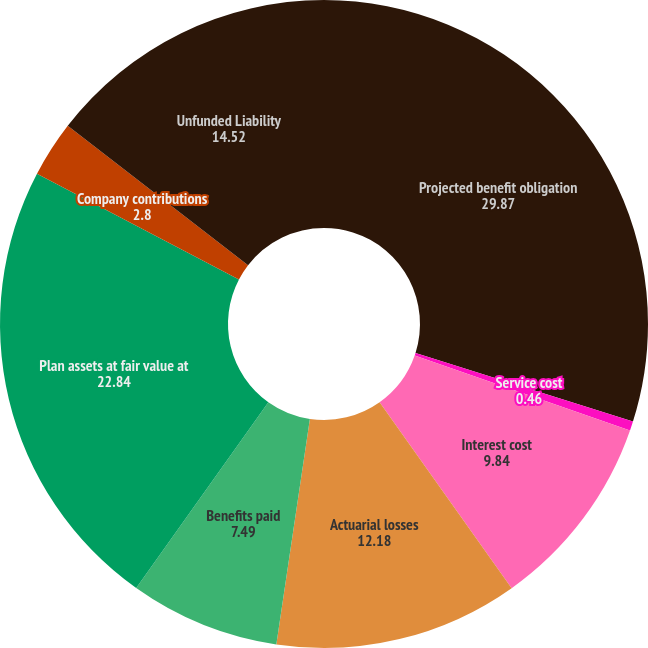<chart> <loc_0><loc_0><loc_500><loc_500><pie_chart><fcel>Projected benefit obligation<fcel>Service cost<fcel>Interest cost<fcel>Actuarial losses<fcel>Benefits paid<fcel>Plan assets at fair value at<fcel>Company contributions<fcel>Unfunded Liability<nl><fcel>29.87%<fcel>0.46%<fcel>9.84%<fcel>12.18%<fcel>7.49%<fcel>22.84%<fcel>2.8%<fcel>14.52%<nl></chart> 